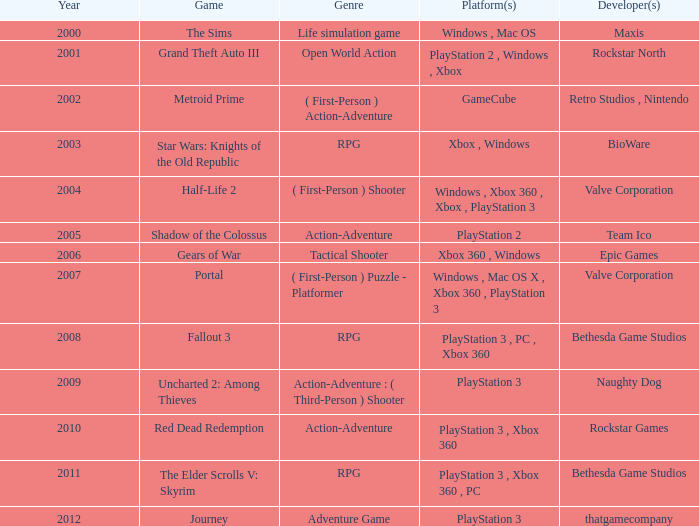What's the platform with rockstar games as the creator? PlayStation 3 , Xbox 360. 